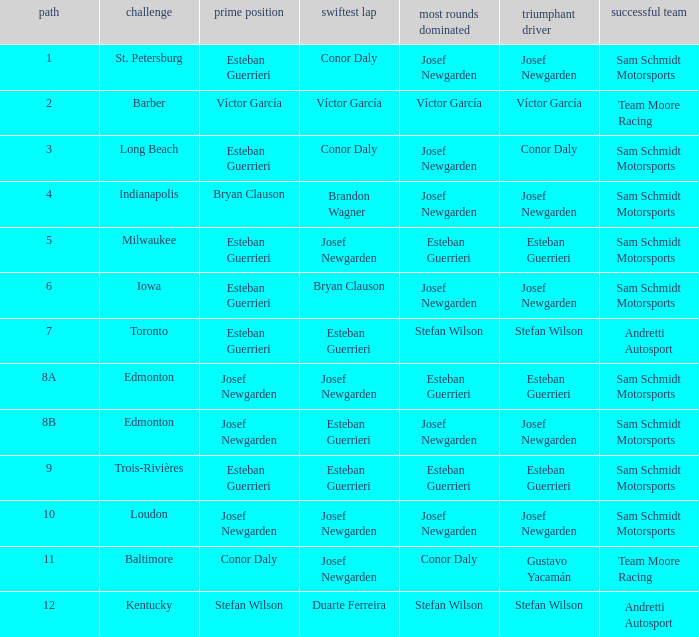Who had the pole(s) when esteban guerrieri led the most laps round 8a and josef newgarden had the fastest lap? Josef Newgarden. 